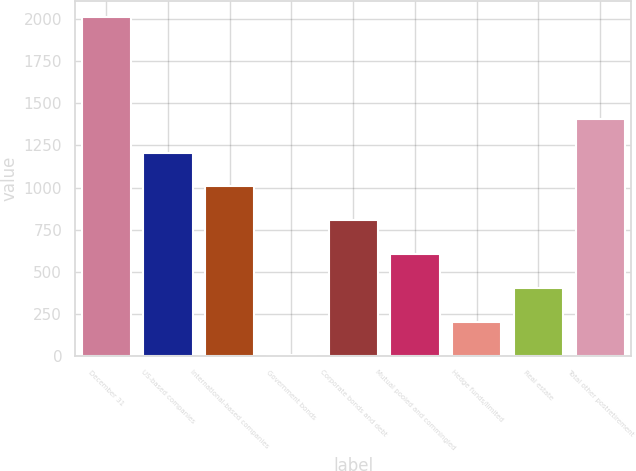Convert chart to OTSL. <chart><loc_0><loc_0><loc_500><loc_500><bar_chart><fcel>December 31<fcel>US-based companies<fcel>International-based companies<fcel>Government bonds<fcel>Corporate bonds and debt<fcel>Mutual pooled and commingled<fcel>Hedge funds/limited<fcel>Real estate<fcel>Total other postretirement<nl><fcel>2011<fcel>1207.4<fcel>1006.5<fcel>2<fcel>805.6<fcel>604.7<fcel>202.9<fcel>403.8<fcel>1408.3<nl></chart> 